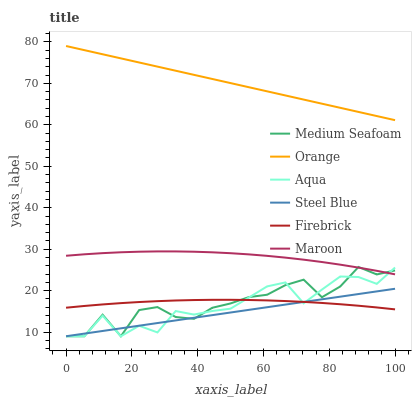Does Steel Blue have the minimum area under the curve?
Answer yes or no. Yes. Does Orange have the maximum area under the curve?
Answer yes or no. Yes. Does Aqua have the minimum area under the curve?
Answer yes or no. No. Does Aqua have the maximum area under the curve?
Answer yes or no. No. Is Steel Blue the smoothest?
Answer yes or no. Yes. Is Medium Seafoam the roughest?
Answer yes or no. Yes. Is Aqua the smoothest?
Answer yes or no. No. Is Aqua the roughest?
Answer yes or no. No. Does Aqua have the lowest value?
Answer yes or no. Yes. Does Maroon have the lowest value?
Answer yes or no. No. Does Orange have the highest value?
Answer yes or no. Yes. Does Aqua have the highest value?
Answer yes or no. No. Is Medium Seafoam less than Orange?
Answer yes or no. Yes. Is Orange greater than Firebrick?
Answer yes or no. Yes. Does Maroon intersect Aqua?
Answer yes or no. Yes. Is Maroon less than Aqua?
Answer yes or no. No. Is Maroon greater than Aqua?
Answer yes or no. No. Does Medium Seafoam intersect Orange?
Answer yes or no. No. 